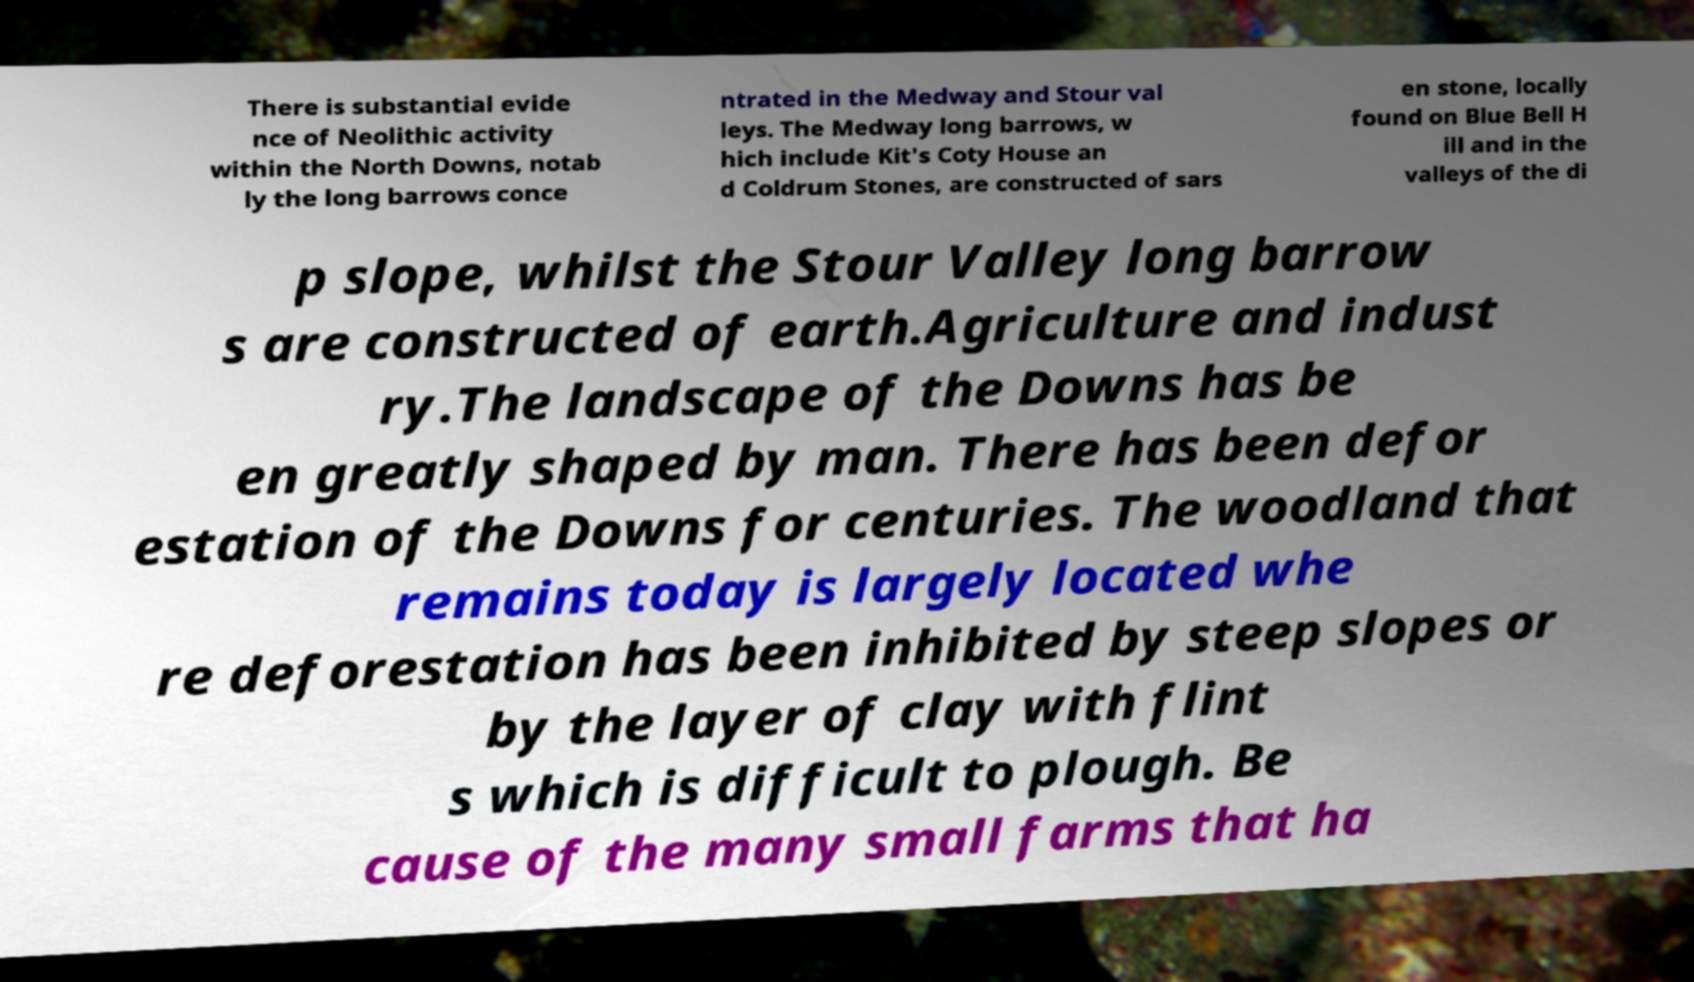Could you assist in decoding the text presented in this image and type it out clearly? There is substantial evide nce of Neolithic activity within the North Downs, notab ly the long barrows conce ntrated in the Medway and Stour val leys. The Medway long barrows, w hich include Kit's Coty House an d Coldrum Stones, are constructed of sars en stone, locally found on Blue Bell H ill and in the valleys of the di p slope, whilst the Stour Valley long barrow s are constructed of earth.Agriculture and indust ry.The landscape of the Downs has be en greatly shaped by man. There has been defor estation of the Downs for centuries. The woodland that remains today is largely located whe re deforestation has been inhibited by steep slopes or by the layer of clay with flint s which is difficult to plough. Be cause of the many small farms that ha 